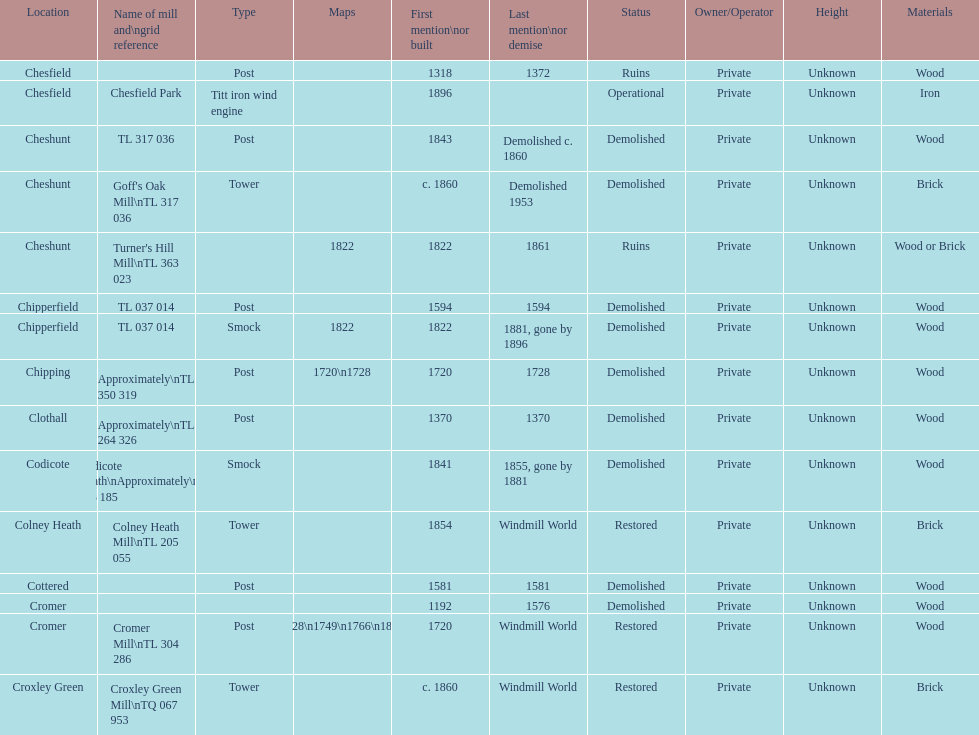What is the total number of mills named cheshunt? 3. 